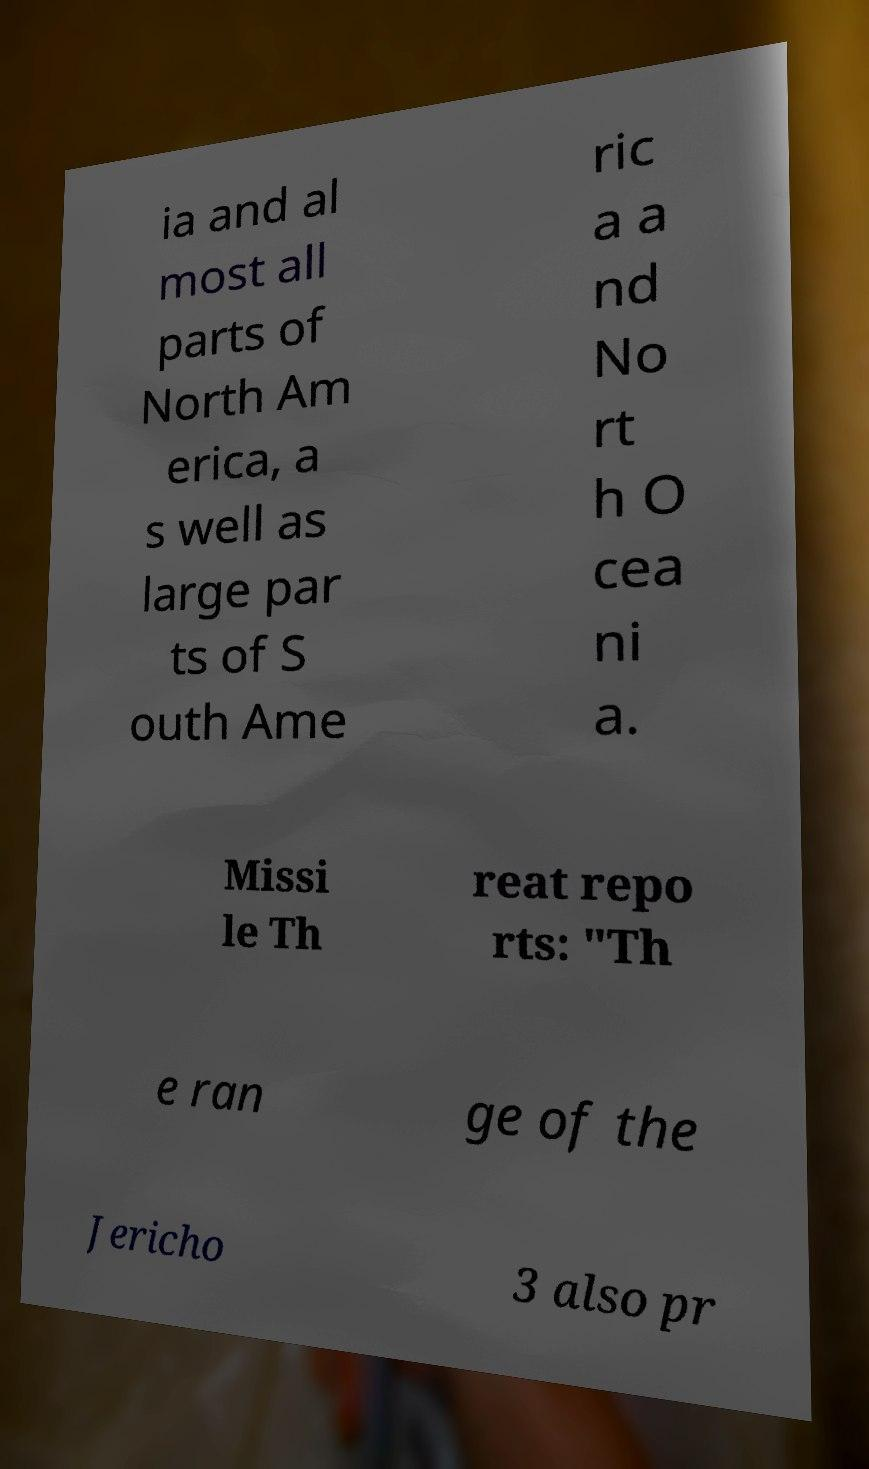Please identify and transcribe the text found in this image. ia and al most all parts of North Am erica, a s well as large par ts of S outh Ame ric a a nd No rt h O cea ni a. Missi le Th reat repo rts: "Th e ran ge of the Jericho 3 also pr 